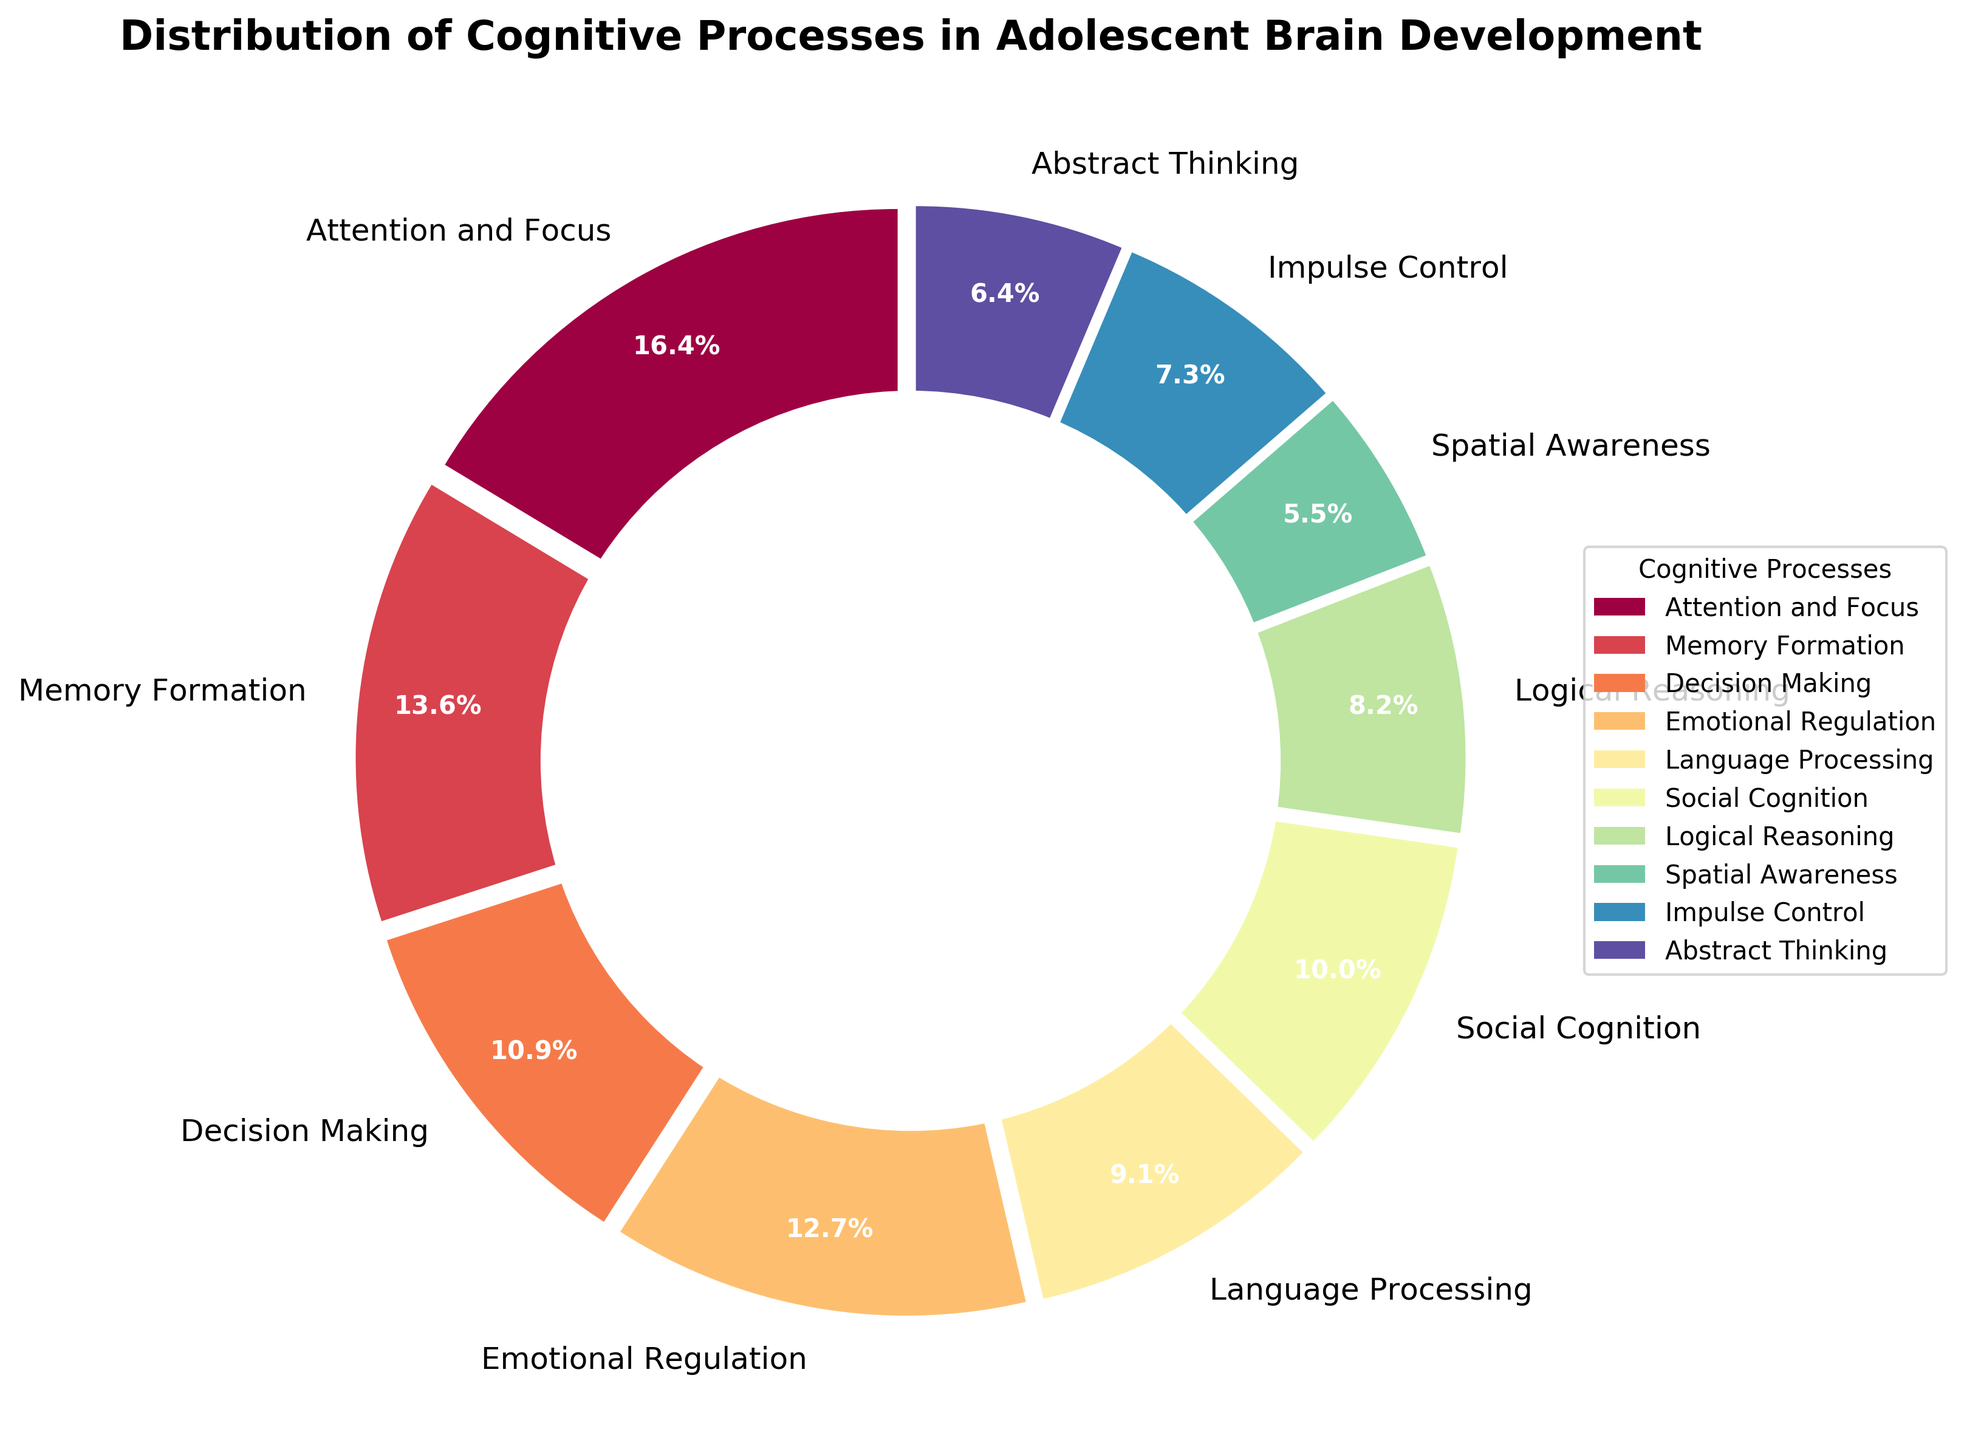What's the percentage of emotional regulation in adolescent brain development? Identify the section labeled "Emotional Regulation" in the pie chart and read its percentage.
Answer: 14% Which cognitive process occupies the largest portion of the pie chart? Observe the pie chart and identify the segment with the largest area. The label shows "Attention and Focus."
Answer: Attention and Focus What is the combined percentage of memory formation and social cognition? Find the percentages for "Memory Formation" and "Social Cognition" on the pie chart (15% and 11%), then add them together: 15% + 11% = 26%.
Answer: 26% Is language processing more or less than logical reasoning? Compare the percentage of the "Language Processing" segment (10%) with "Logical Reasoning" (9%) on the pie chart. 10% is more than 9%.
Answer: More What is the difference in percentage between decision making and abstract thinking? Locate the percentages for "Decision Making" (12%) and "Abstract Thinking" (7%), then subtract the smaller percentage from the larger one: 12% - 7% = 5%.
Answer: 5% Which cognitive process has the smallest percentage, and what is it? Find the segment with the smallest area on the pie chart and read its label. The smallest segment is "Spatial Awareness."
Answer: Spatial Awareness, 6% What is the sum of the percentages for decision making, impulse control, and language processing? Identify the percentages for "Decision Making" (12%), "Impulse Control" (8%), and "Language Processing" (10%), then add them together: 12% + 8% + 10% = 30%.
Answer: 30% Are there any cognitive processes that have the same percentage? Examine each segment of the pie chart individually to compare the percentages and see if any two are equal. The chart shows no two processes have the same percentage.
Answer: No 